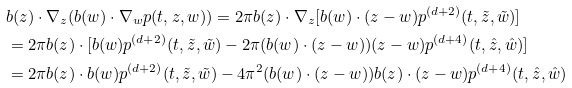Convert formula to latex. <formula><loc_0><loc_0><loc_500><loc_500>& b ( z ) \cdot \nabla _ { z } ( b ( w ) \cdot \nabla _ { w } p ( t , z , w ) ) = 2 \pi b ( z ) \cdot \nabla _ { z } [ b ( w ) \cdot ( z - w ) p ^ { ( d + 2 ) } ( t , \tilde { z } , \tilde { w } ) ] \\ & = 2 \pi b ( z ) \cdot [ b ( w ) p ^ { ( d + 2 ) } ( t , \tilde { z } , \tilde { w } ) - 2 \pi ( b ( w ) \cdot ( z - w ) ) ( z - w ) p ^ { ( d + 4 ) } ( t , \hat { z } , \hat { w } ) ] \\ & = 2 \pi b ( z ) \cdot b ( w ) p ^ { ( d + 2 ) } ( t , \tilde { z } , \tilde { w } ) - 4 \pi ^ { 2 } ( b ( w ) \cdot ( z - w ) ) b ( z ) \cdot ( z - w ) p ^ { ( d + 4 ) } ( t , \hat { z } , \hat { w } )</formula> 